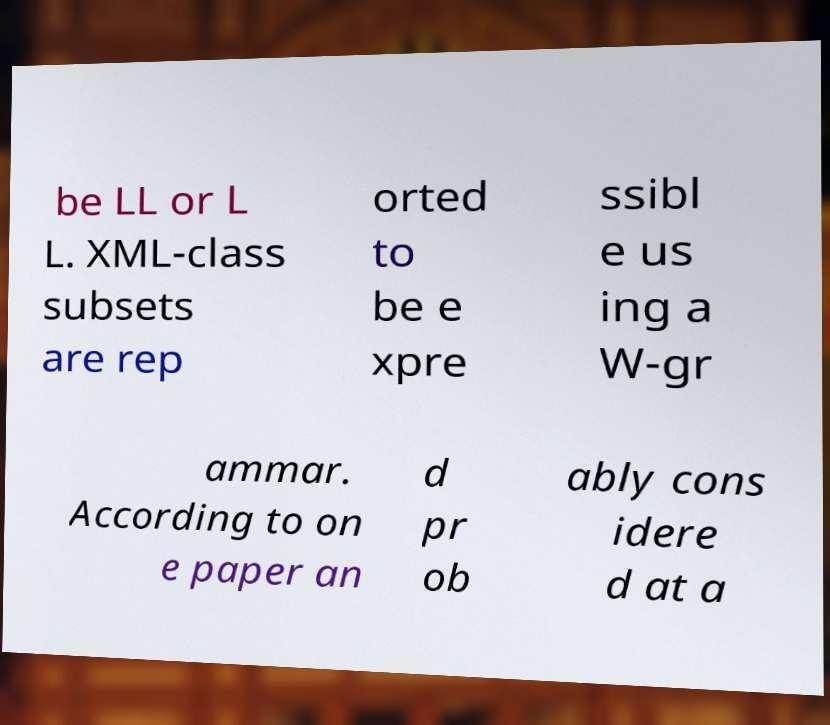Could you assist in decoding the text presented in this image and type it out clearly? be LL or L L. XML-class subsets are rep orted to be e xpre ssibl e us ing a W-gr ammar. According to on e paper an d pr ob ably cons idere d at a 